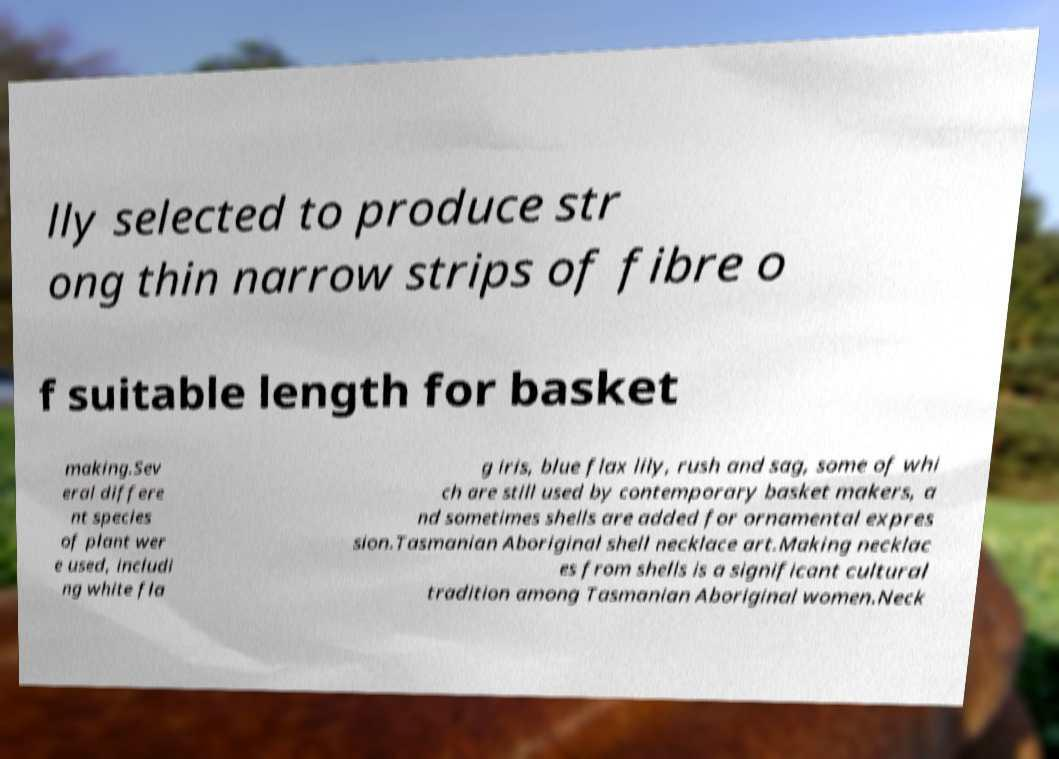Can you accurately transcribe the text from the provided image for me? lly selected to produce str ong thin narrow strips of fibre o f suitable length for basket making.Sev eral differe nt species of plant wer e used, includi ng white fla g iris, blue flax lily, rush and sag, some of whi ch are still used by contemporary basket makers, a nd sometimes shells are added for ornamental expres sion.Tasmanian Aboriginal shell necklace art.Making necklac es from shells is a significant cultural tradition among Tasmanian Aboriginal women.Neck 